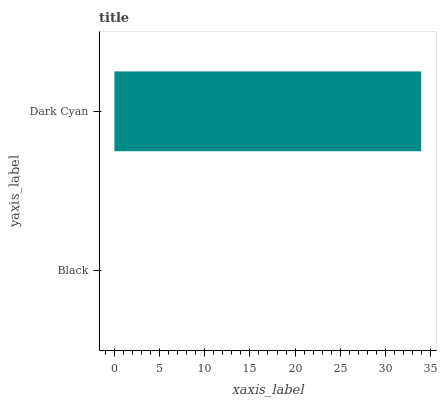Is Black the minimum?
Answer yes or no. Yes. Is Dark Cyan the maximum?
Answer yes or no. Yes. Is Dark Cyan the minimum?
Answer yes or no. No. Is Dark Cyan greater than Black?
Answer yes or no. Yes. Is Black less than Dark Cyan?
Answer yes or no. Yes. Is Black greater than Dark Cyan?
Answer yes or no. No. Is Dark Cyan less than Black?
Answer yes or no. No. Is Dark Cyan the high median?
Answer yes or no. Yes. Is Black the low median?
Answer yes or no. Yes. Is Black the high median?
Answer yes or no. No. Is Dark Cyan the low median?
Answer yes or no. No. 